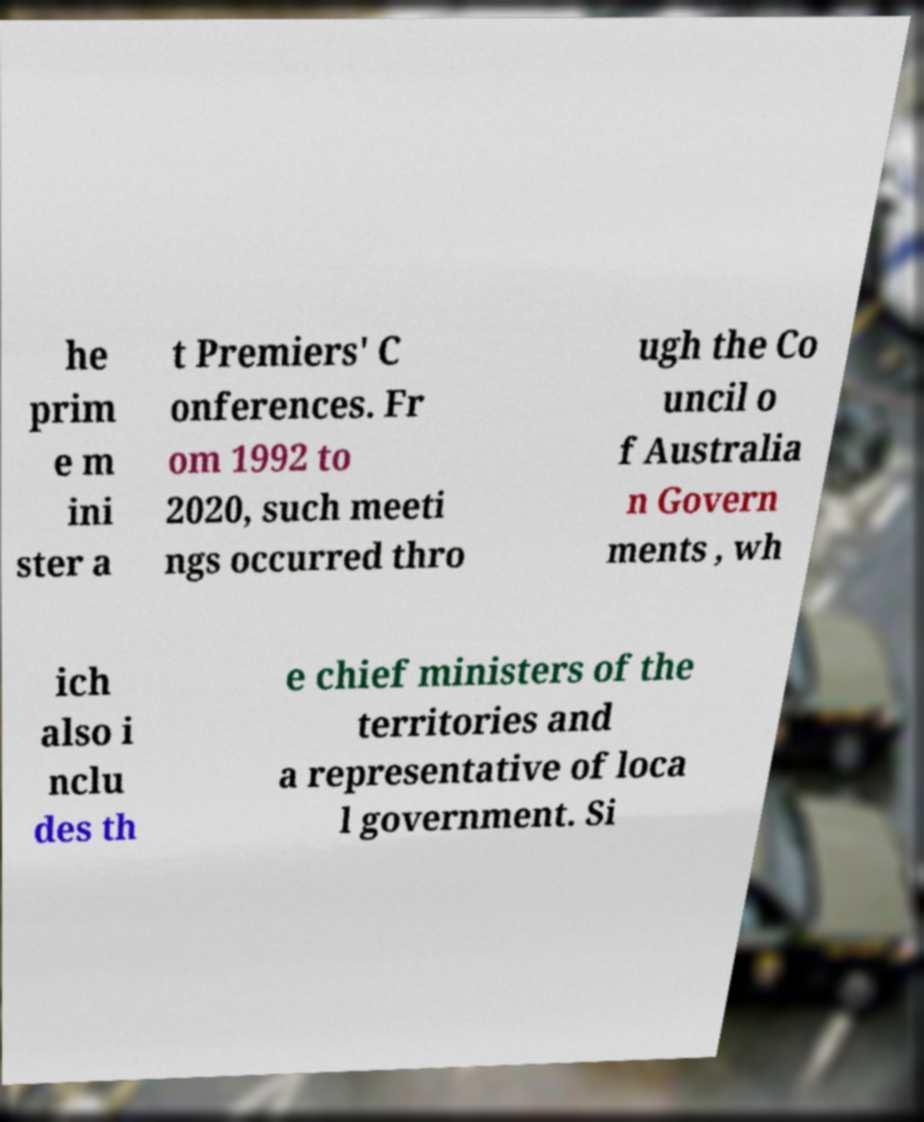Can you read and provide the text displayed in the image?This photo seems to have some interesting text. Can you extract and type it out for me? he prim e m ini ster a t Premiers' C onferences. Fr om 1992 to 2020, such meeti ngs occurred thro ugh the Co uncil o f Australia n Govern ments , wh ich also i nclu des th e chief ministers of the territories and a representative of loca l government. Si 